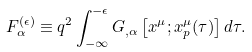<formula> <loc_0><loc_0><loc_500><loc_500>F ^ { ( \epsilon ) } _ { \alpha } \equiv q ^ { 2 } \int _ { - \infty } ^ { - \epsilon } G _ { , \alpha } \left [ x ^ { \mu } ; x _ { p } ^ { \mu } ( \tau ) \right ] d \tau .</formula> 